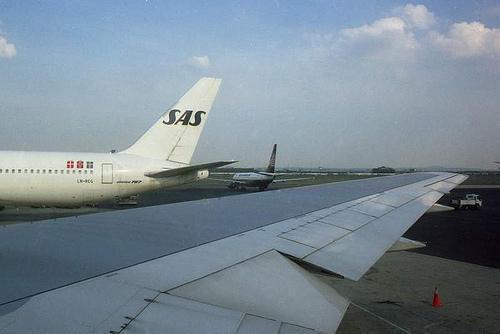How many planes are there?
Give a very brief answer. 3. 